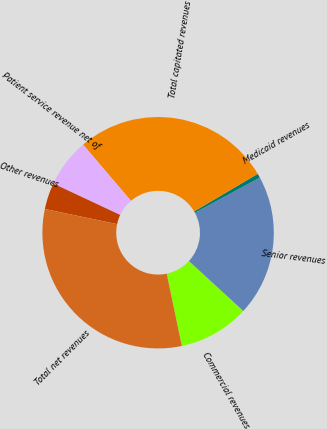Convert chart. <chart><loc_0><loc_0><loc_500><loc_500><pie_chart><fcel>Commercial revenues<fcel>Senior revenues<fcel>Medicaid revenues<fcel>Total capitated revenues<fcel>Patient service revenue net of<fcel>Other revenues<fcel>Total net revenues<nl><fcel>9.89%<fcel>19.72%<fcel>0.6%<fcel>27.73%<fcel>6.79%<fcel>3.69%<fcel>31.57%<nl></chart> 